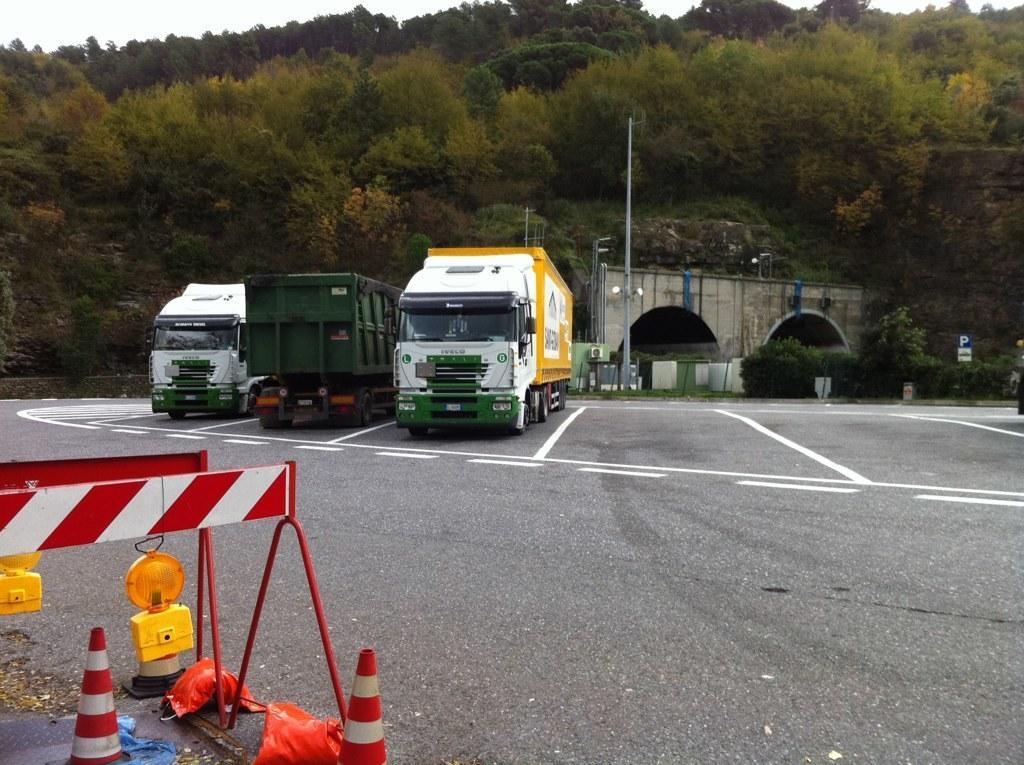Please provide a concise description of this image. These are vehicles on the road, these are trees. 